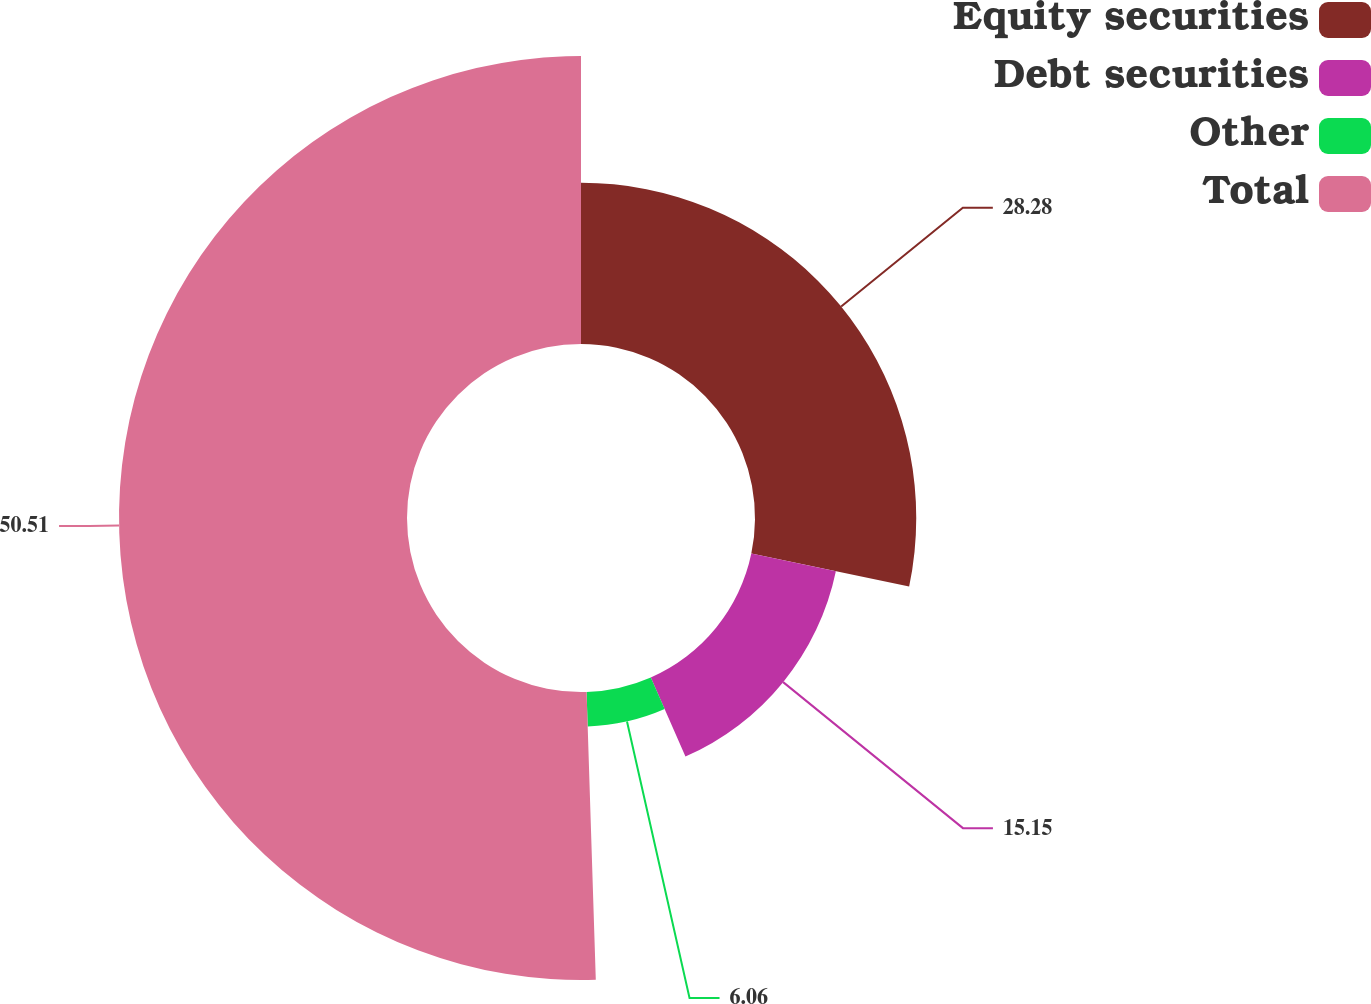Convert chart. <chart><loc_0><loc_0><loc_500><loc_500><pie_chart><fcel>Equity securities<fcel>Debt securities<fcel>Other<fcel>Total<nl><fcel>28.28%<fcel>15.15%<fcel>6.06%<fcel>50.51%<nl></chart> 